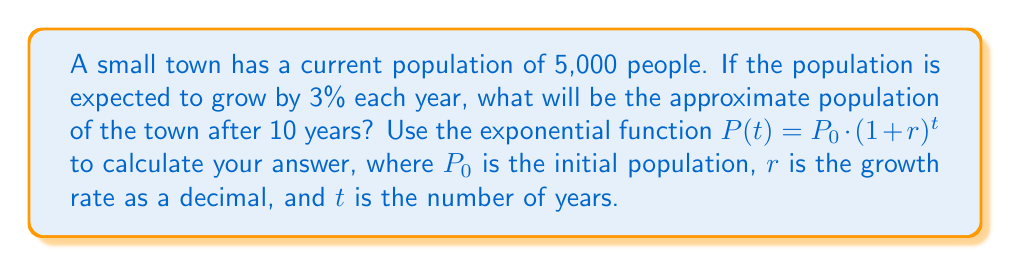Teach me how to tackle this problem. To solve this problem, we'll use the exponential growth function:

$$P(t) = P_0 \cdot (1 + r)^t$$

Where:
- $P(t)$ is the population after $t$ years
- $P_0$ is the initial population (5,000)
- $r$ is the growth rate as a decimal (3% = 0.03)
- $t$ is the number of years (10)

Let's plug in the values:

$$P(10) = 5000 \cdot (1 + 0.03)^{10}$$

Now, we need to calculate this step by step:

1. Calculate $(1 + 0.03)$:
   $1 + 0.03 = 1.03$

2. Calculate $(1.03)^{10}$:
   $1.03^{10} \approx 1.3439$ (rounded to 4 decimal places)

3. Multiply the result by the initial population:
   $5000 \cdot 1.3439 \approx 6719.58$

4. Round the result to the nearest whole number:
   $6719.58 \approx 6720$

Therefore, after 10 years, the approximate population of the town will be 6,720 people.
Answer: 6,720 people 